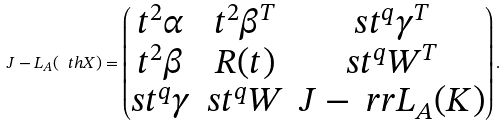Convert formula to latex. <formula><loc_0><loc_0><loc_500><loc_500>J - L _ { A } ( \ t h X ) = \begin{pmatrix} t ^ { 2 } \alpha & t ^ { 2 } \beta ^ { T } & s t ^ { q } \gamma ^ { T } \\ t ^ { 2 } \beta & R ( t ) & s t ^ { q } W ^ { T } \\ s t ^ { q } \gamma & s t ^ { q } W & J - \ r r L _ { A } ( K ) \end{pmatrix} .</formula> 